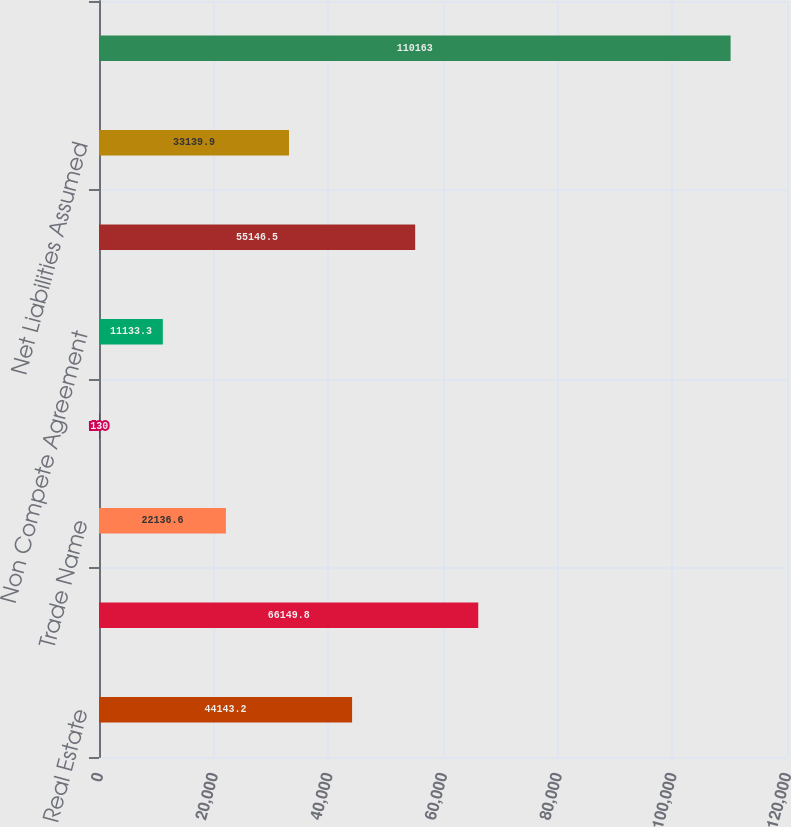Convert chart to OTSL. <chart><loc_0><loc_0><loc_500><loc_500><bar_chart><fcel>Real Estate<fcel>Customer Contracts<fcel>Trade Name<fcel>Patents<fcel>Non Compete Agreement<fcel>Goodwill<fcel>Net Liabilities Assumed<fcel>Net Purchase Price<nl><fcel>44143.2<fcel>66149.8<fcel>22136.6<fcel>130<fcel>11133.3<fcel>55146.5<fcel>33139.9<fcel>110163<nl></chart> 